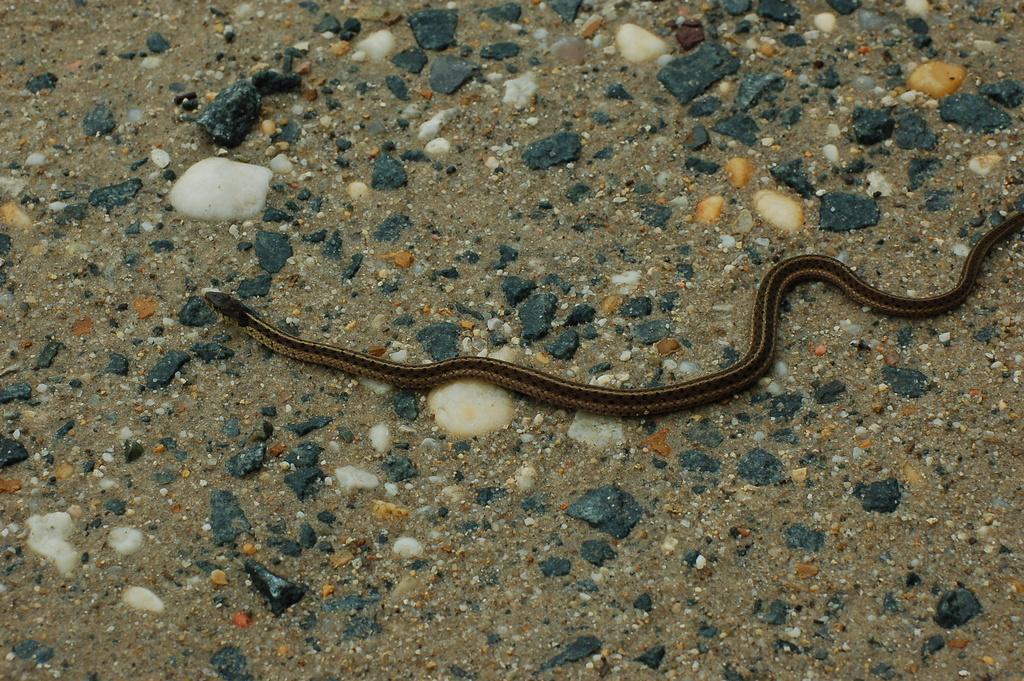Could you give a brief overview of what you see in this image? In this image we can see a snake. And some stones. 